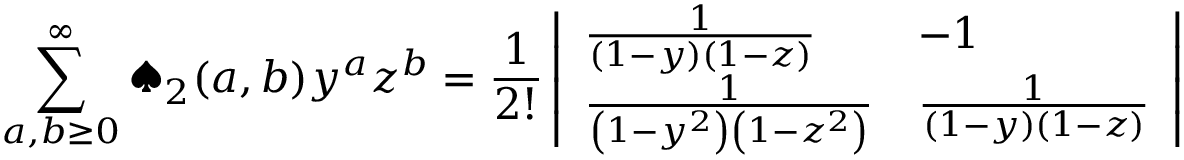Convert formula to latex. <formula><loc_0><loc_0><loc_500><loc_500>\sum _ { a , b \geq 0 } ^ { \infty } ^ { a } d e s u i t _ { 2 } ( a , b ) y ^ { a } z ^ { b } = \frac { 1 } { 2 ! } \left | \begin{array} { l l } { \frac { 1 } { \left ( 1 - y \right ) \left ( 1 - z \right ) } } & { - 1 } \\ { \frac { 1 } { \left ( 1 - y ^ { 2 } \right ) \left ( 1 - z ^ { 2 } \right ) } } & { \frac { 1 } { \left ( 1 - y \right ) \left ( 1 - z \right ) } } \end{array} \right |</formula> 